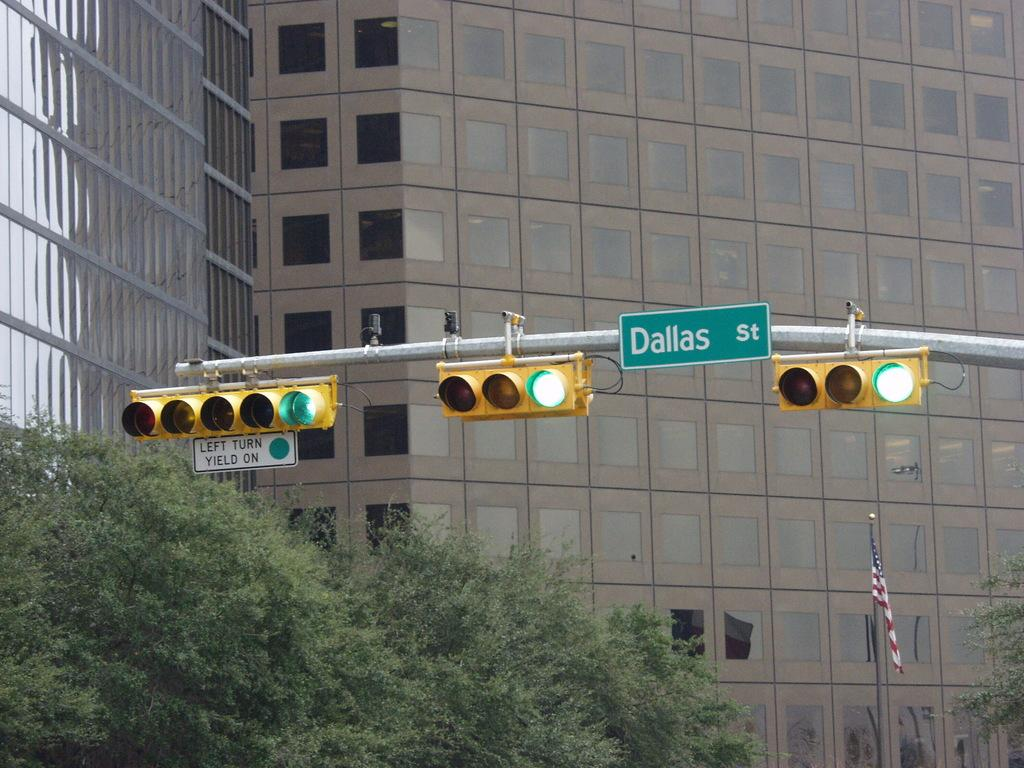What type of structures can be seen in the image? Buildings are visible in the image. What objects are related to traffic management in the image? There are traffic poles and traffic signals in the image. What type of signage is present in the image? Name boards are present in the image. What type of vegetation can be seen in the image? There are trees in the image. What national symbol is visible in the image? There is a flag on a flag post in the image. What type of can is being used to serve breakfast in the image? There is no can or breakfast present in the image. What type of cord is attached to the flag in the image? There is no cord visible in the image; the flag is on a flag post. 